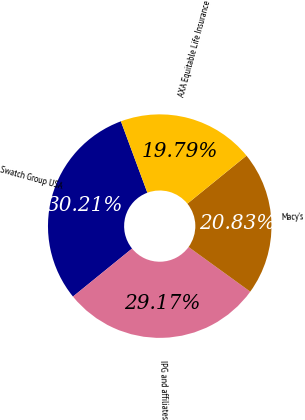Convert chart to OTSL. <chart><loc_0><loc_0><loc_500><loc_500><pie_chart><fcel>Swatch Group USA<fcel>IPG and affiliates<fcel>Macy's<fcel>AXA Equitable Life Insurance<nl><fcel>30.21%<fcel>29.17%<fcel>20.83%<fcel>19.79%<nl></chart> 